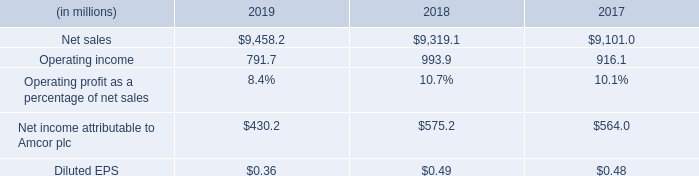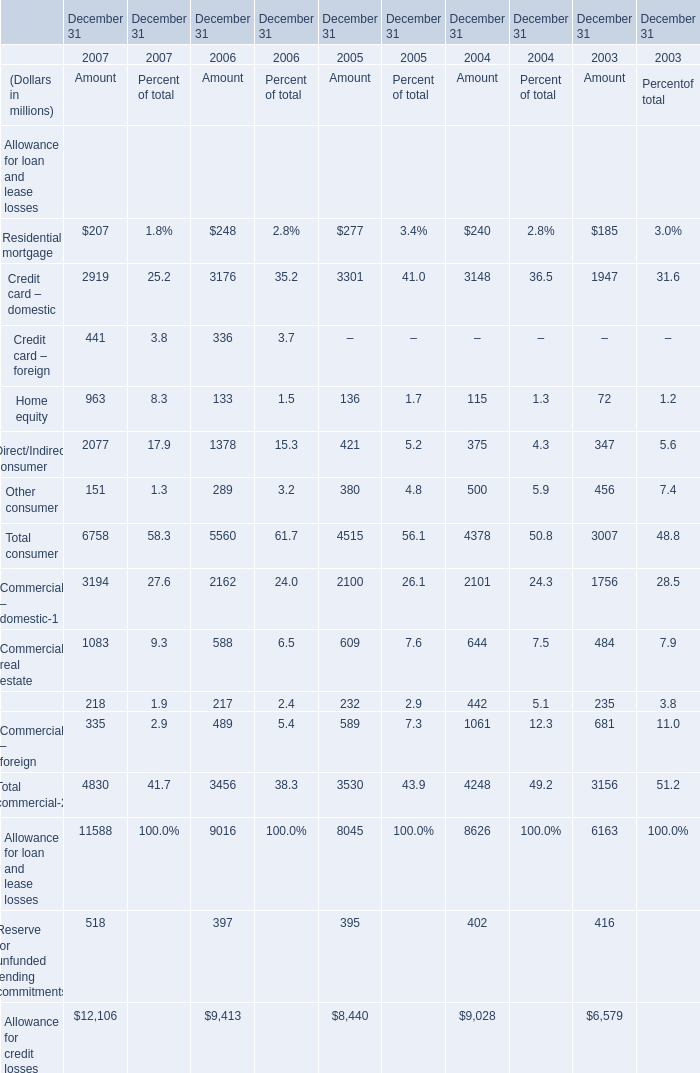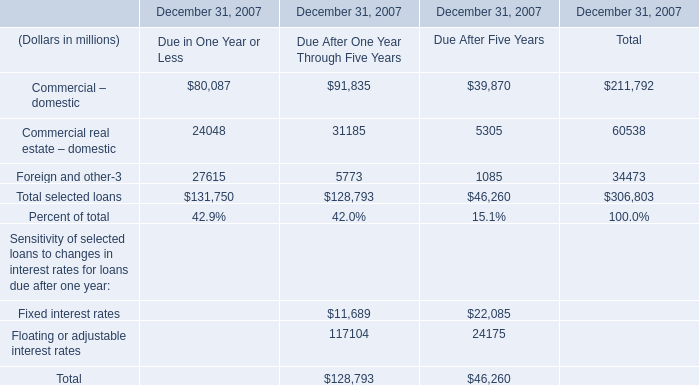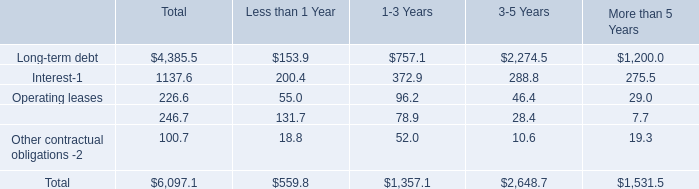What is the total amount of Commercial – foreign of December 31 2004 Amount, and Net sales of 2018 ? 
Computations: (1061.0 + 9319.1)
Answer: 10380.1. 